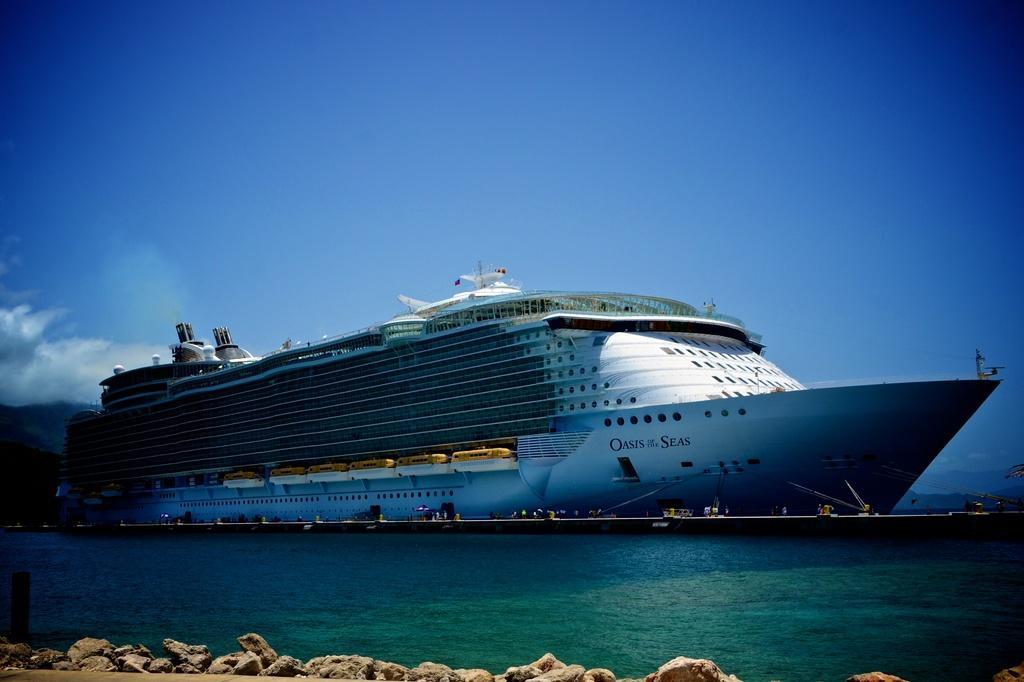Describe this image in one or two sentences. In this image I can see ship visible on the lake and a the bottom I can see some stones and at the top I can see the sky 